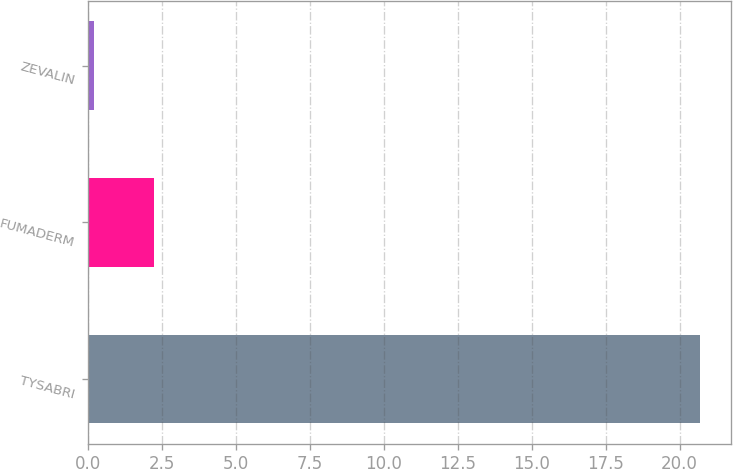Convert chart to OTSL. <chart><loc_0><loc_0><loc_500><loc_500><bar_chart><fcel>TYSABRI<fcel>FUMADERM<fcel>ZEVALIN<nl><fcel>20.7<fcel>2.25<fcel>0.2<nl></chart> 